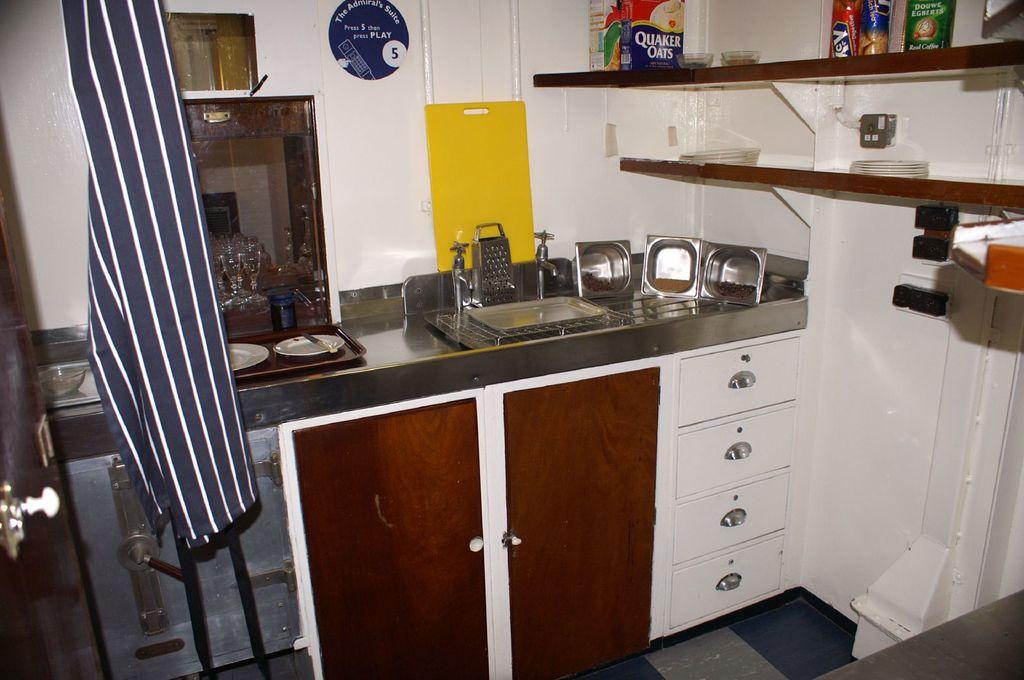What brand of oats are in this kitchen?
Make the answer very short. Quaker. 